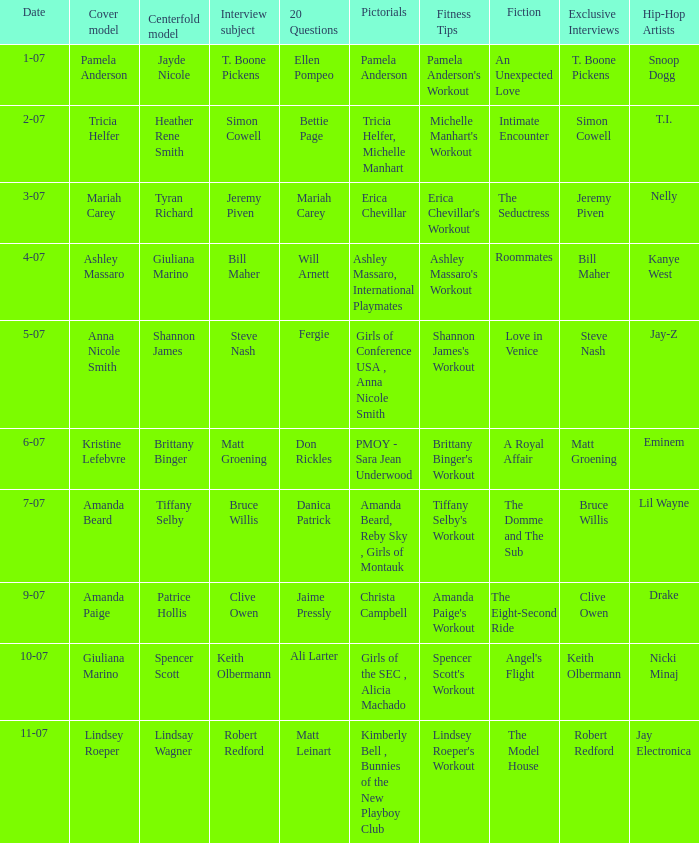Who was the centerfold model in the issue where Fergie answered the "20 questions"? Shannon James. 